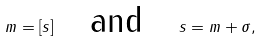Convert formula to latex. <formula><loc_0><loc_0><loc_500><loc_500>m = [ s ] \quad \text {and} \quad s = m + \sigma ,</formula> 